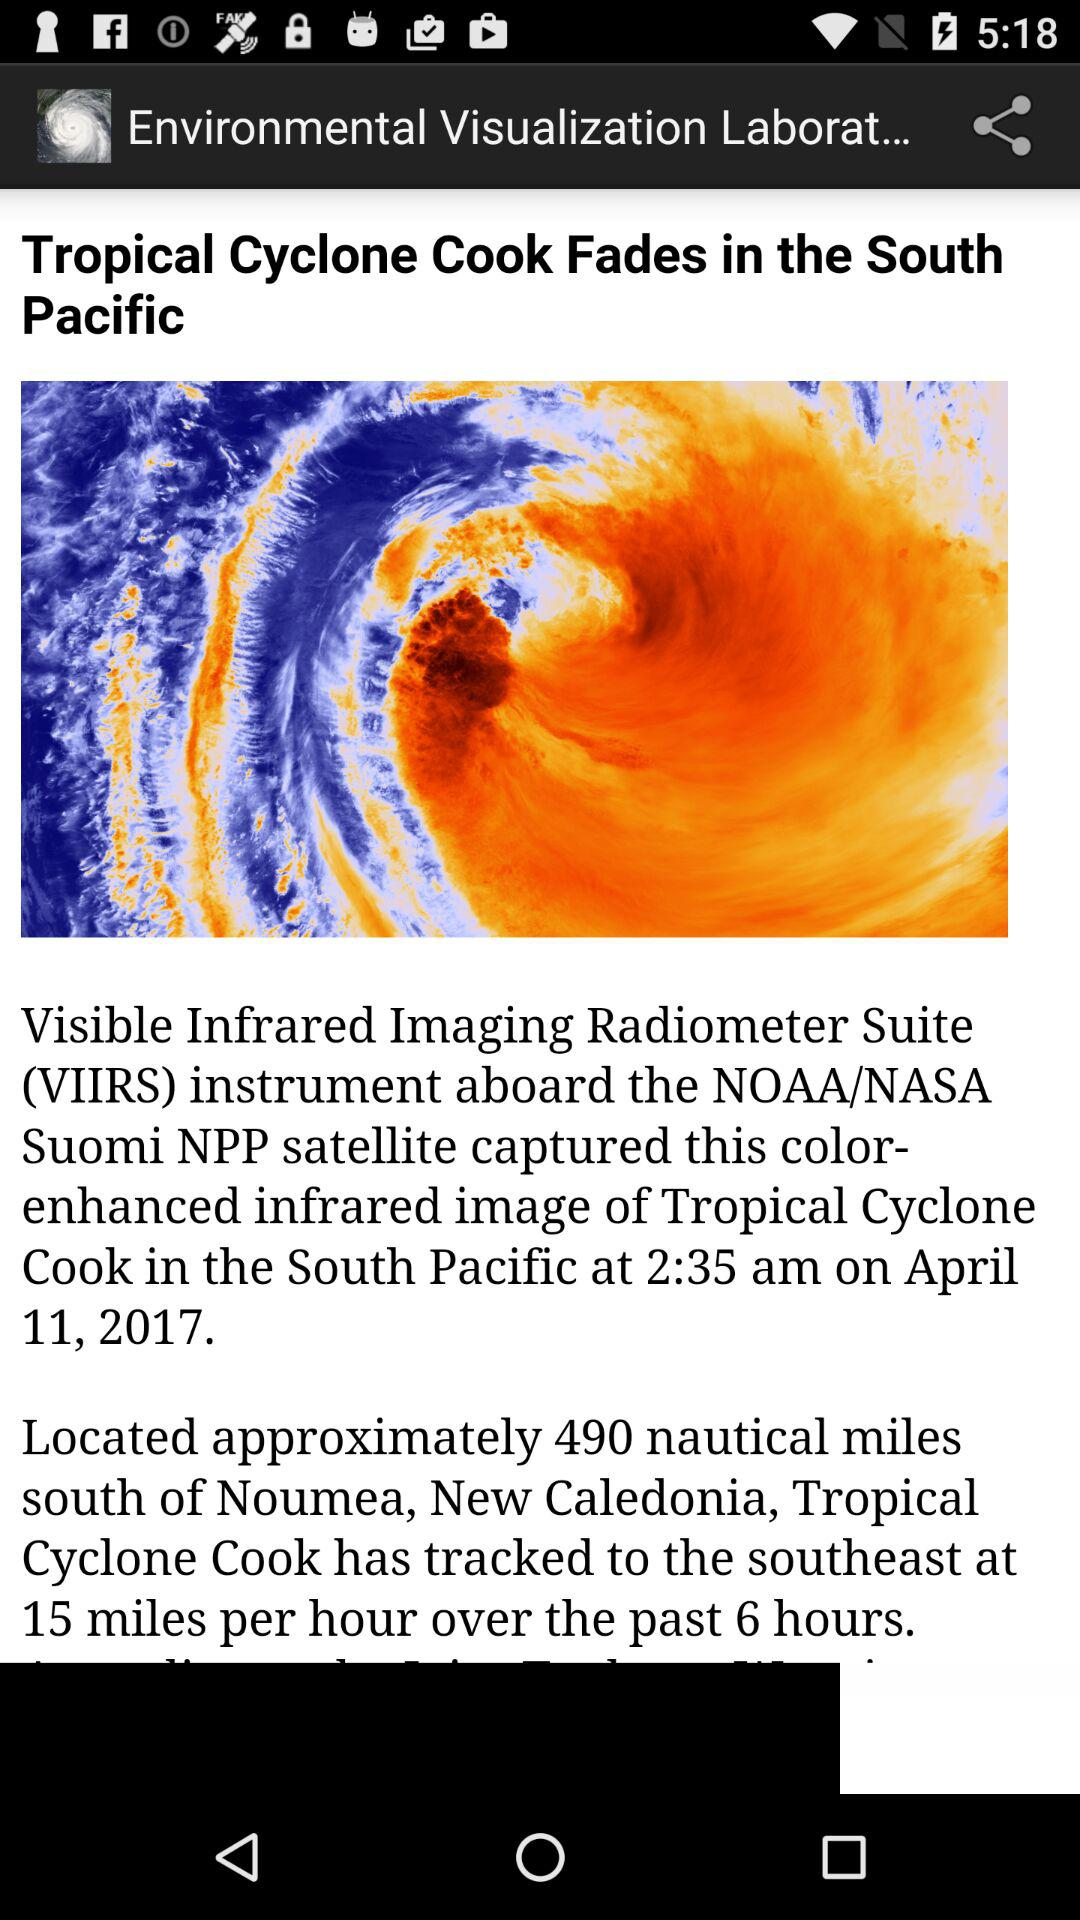What is the mentioned date? The mentioned date is April 11, 2017. 